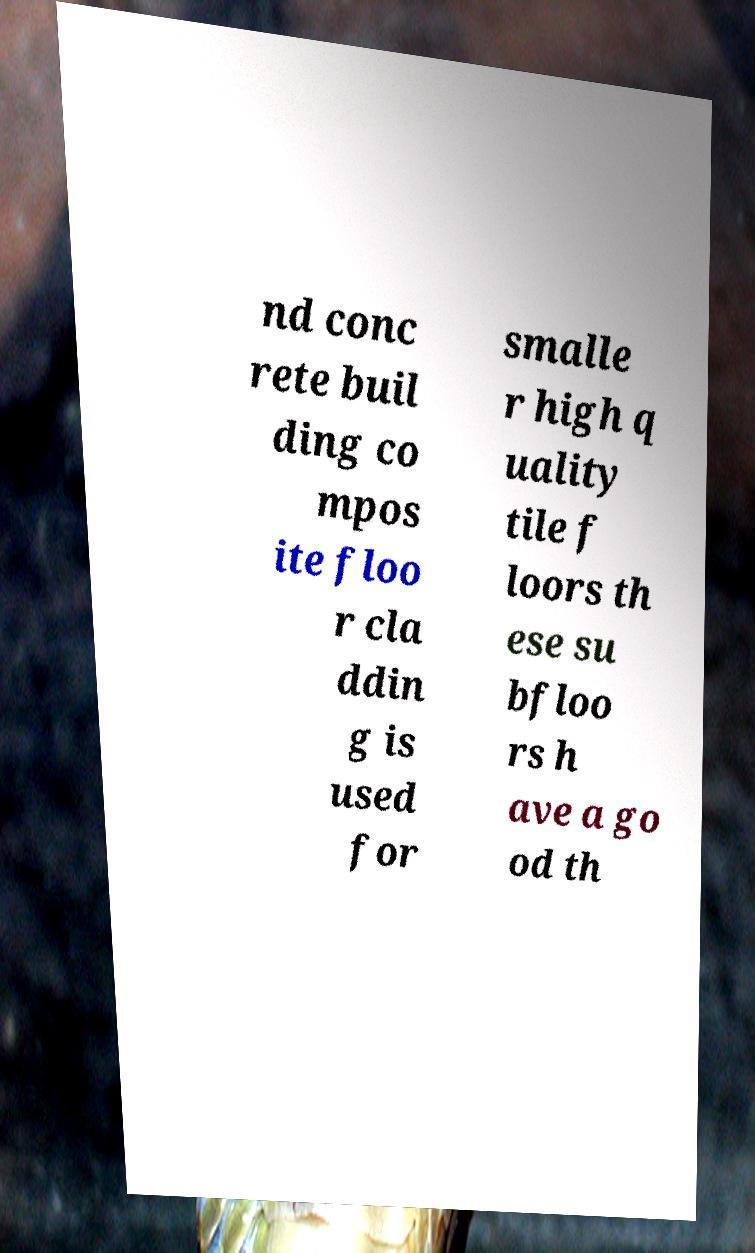Can you read and provide the text displayed in the image?This photo seems to have some interesting text. Can you extract and type it out for me? nd conc rete buil ding co mpos ite floo r cla ddin g is used for smalle r high q uality tile f loors th ese su bfloo rs h ave a go od th 